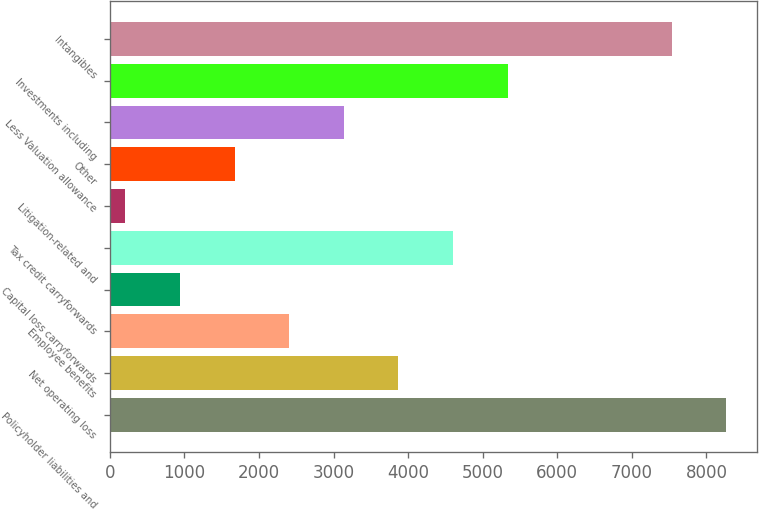Convert chart to OTSL. <chart><loc_0><loc_0><loc_500><loc_500><bar_chart><fcel>Policyholder liabilities and<fcel>Net operating loss<fcel>Employee benefits<fcel>Capital loss carryforwards<fcel>Tax credit carryforwards<fcel>Litigation-related and<fcel>Other<fcel>Less Valuation allowance<fcel>Investments including<fcel>Intangibles<nl><fcel>8267.8<fcel>3871<fcel>2405.4<fcel>939.8<fcel>4603.8<fcel>207<fcel>1672.6<fcel>3138.2<fcel>5336.6<fcel>7535<nl></chart> 